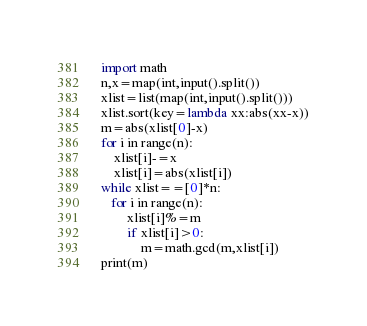Convert code to text. <code><loc_0><loc_0><loc_500><loc_500><_Python_>import math
n,x=map(int,input().split())
xlist=list(map(int,input().split()))
xlist.sort(key=lambda xx:abs(xx-x))
m=abs(xlist[0]-x)
for i in range(n):
    xlist[i]-=x
    xlist[i]=abs(xlist[i])
while xlist==[0]*n:
   for i in range(n):
        xlist[i]%=m
        if xlist[i]>0:
            m=math.gcd(m,xlist[i])
print(m)</code> 